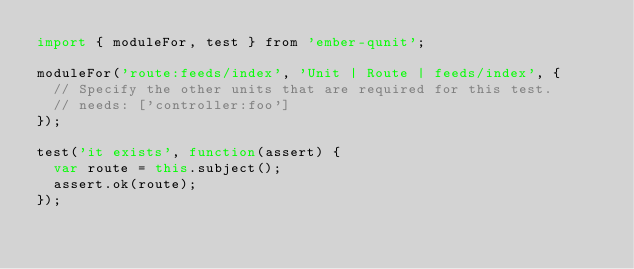<code> <loc_0><loc_0><loc_500><loc_500><_JavaScript_>import { moduleFor, test } from 'ember-qunit';

moduleFor('route:feeds/index', 'Unit | Route | feeds/index', {
  // Specify the other units that are required for this test.
  // needs: ['controller:foo']
});

test('it exists', function(assert) {
  var route = this.subject();
  assert.ok(route);
});
</code> 